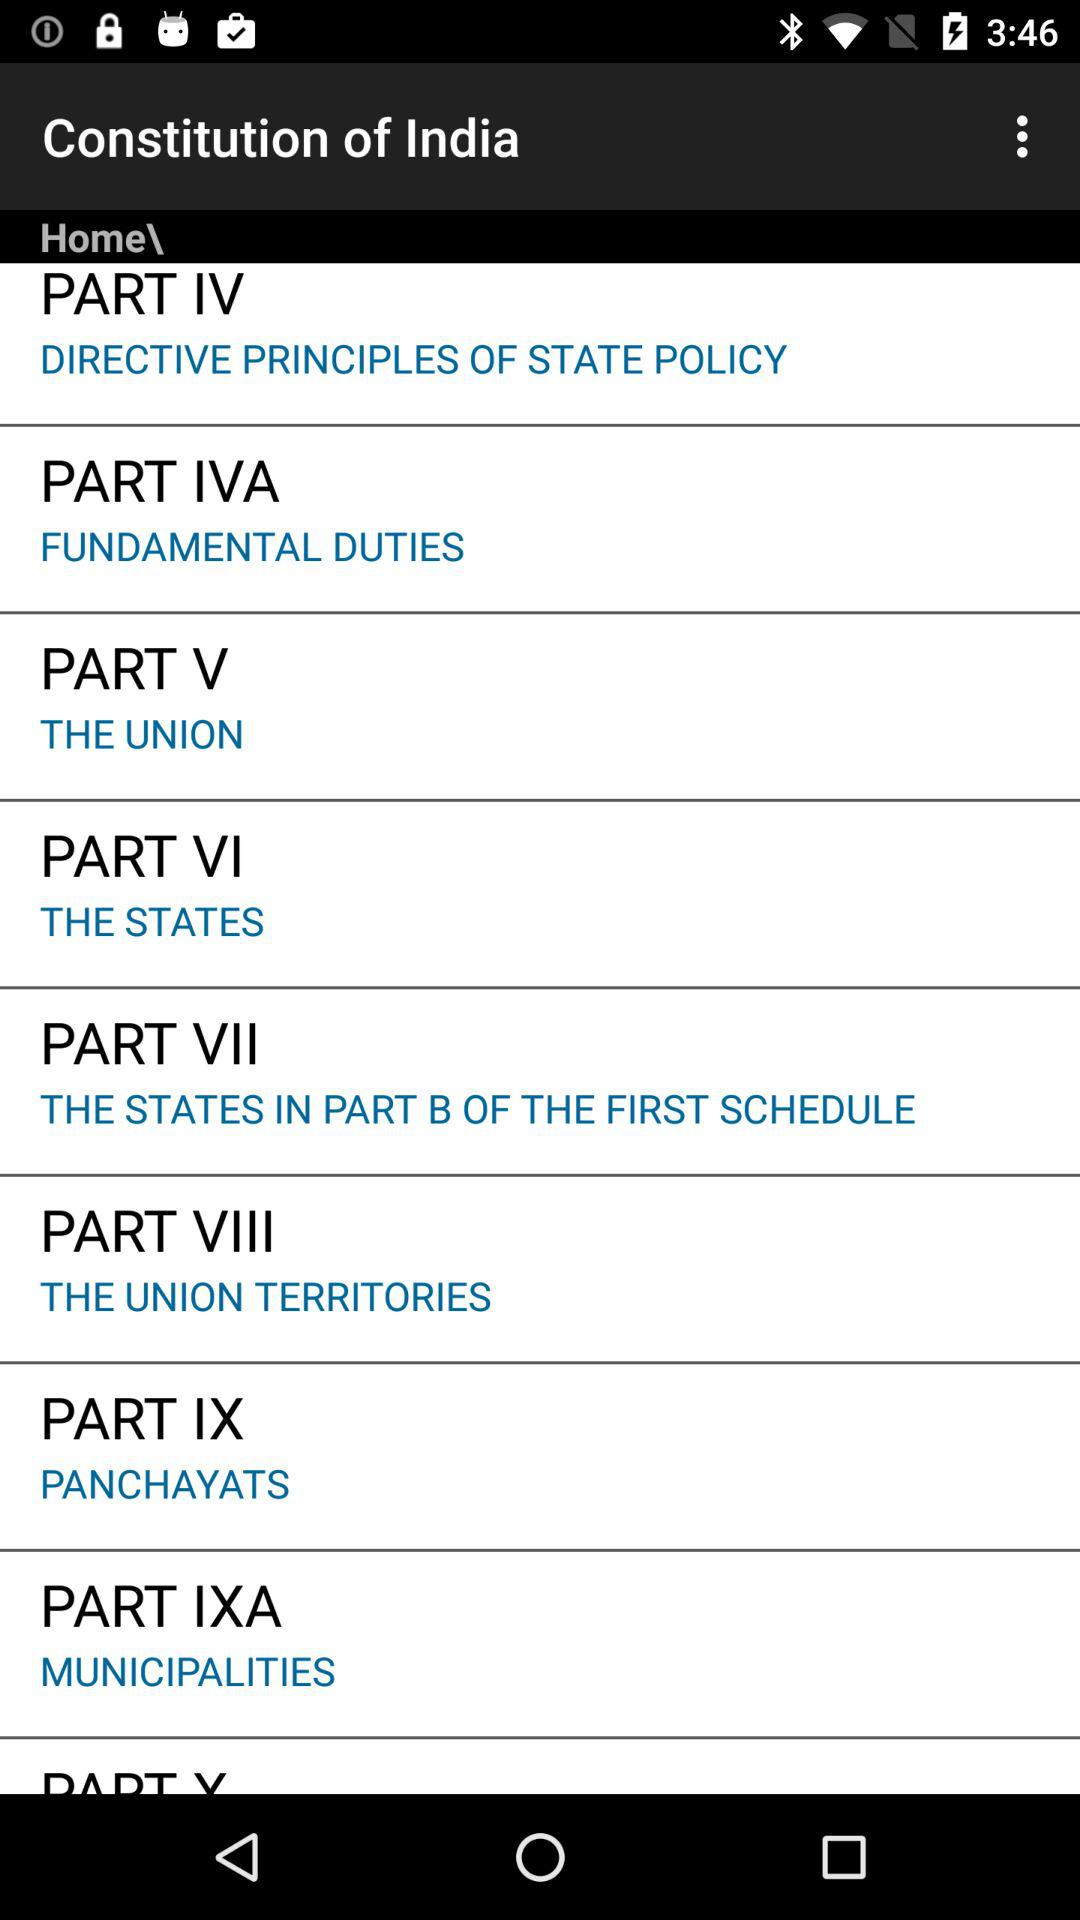What part do the states come under? The states come under part VI. 